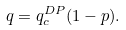Convert formula to latex. <formula><loc_0><loc_0><loc_500><loc_500>q = q _ { c } ^ { D P } ( 1 - p ) .</formula> 